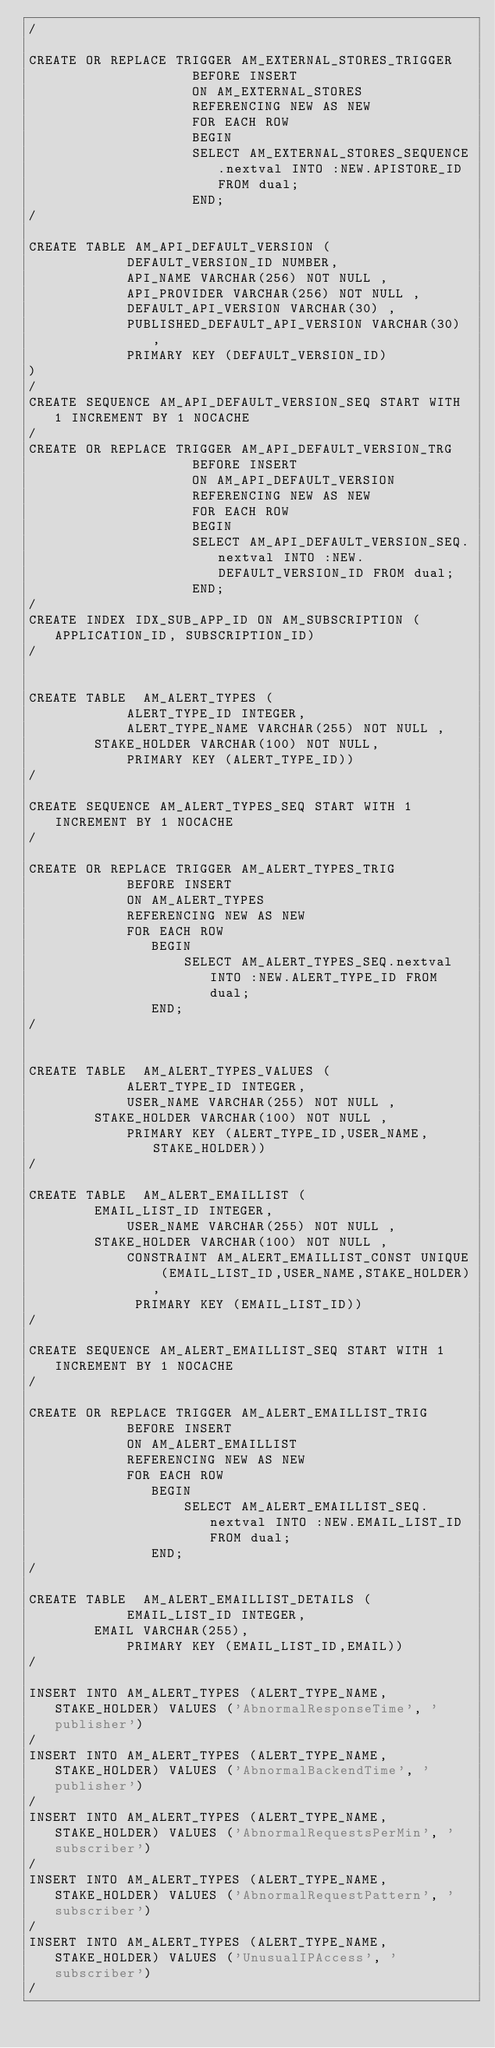<code> <loc_0><loc_0><loc_500><loc_500><_SQL_>/

CREATE OR REPLACE TRIGGER AM_EXTERNAL_STORES_TRIGGER
		            BEFORE INSERT
                    ON AM_EXTERNAL_STORES
                    REFERENCING NEW AS NEW
                    FOR EACH ROW
                    BEGIN
                    SELECT AM_EXTERNAL_STORES_SEQUENCE.nextval INTO :NEW.APISTORE_ID FROM dual;
                    END;
/

CREATE TABLE AM_API_DEFAULT_VERSION (
            DEFAULT_VERSION_ID NUMBER,
            API_NAME VARCHAR(256) NOT NULL ,
            API_PROVIDER VARCHAR(256) NOT NULL ,
            DEFAULT_API_VERSION VARCHAR(30) ,
            PUBLISHED_DEFAULT_API_VERSION VARCHAR(30) ,
            PRIMARY KEY (DEFAULT_VERSION_ID)
)
/
CREATE SEQUENCE AM_API_DEFAULT_VERSION_SEQ START WITH 1 INCREMENT BY 1 NOCACHE
/
CREATE OR REPLACE TRIGGER AM_API_DEFAULT_VERSION_TRG
                    BEFORE INSERT
                    ON AM_API_DEFAULT_VERSION
                    REFERENCING NEW AS NEW
                    FOR EACH ROW
                    BEGIN
                    SELECT AM_API_DEFAULT_VERSION_SEQ.nextval INTO :NEW.DEFAULT_VERSION_ID FROM dual;
                    END;
/
CREATE INDEX IDX_SUB_APP_ID ON AM_SUBSCRIPTION (APPLICATION_ID, SUBSCRIPTION_ID)
/


CREATE TABLE  AM_ALERT_TYPES (
            ALERT_TYPE_ID INTEGER,
            ALERT_TYPE_NAME VARCHAR(255) NOT NULL ,
	    STAKE_HOLDER VARCHAR(100) NOT NULL,
            PRIMARY KEY (ALERT_TYPE_ID))
/

CREATE SEQUENCE AM_ALERT_TYPES_SEQ START WITH 1 INCREMENT BY 1 NOCACHE
/

CREATE OR REPLACE TRIGGER AM_ALERT_TYPES_TRIG
            BEFORE INSERT
            ON AM_ALERT_TYPES
            REFERENCING NEW AS NEW
            FOR EACH ROW
               BEGIN
                   SELECT AM_ALERT_TYPES_SEQ.nextval INTO :NEW.ALERT_TYPE_ID FROM dual;
               END;
/


CREATE TABLE  AM_ALERT_TYPES_VALUES (
            ALERT_TYPE_ID INTEGER,
            USER_NAME VARCHAR(255) NOT NULL ,
	    STAKE_HOLDER VARCHAR(100) NOT NULL ,
	        PRIMARY KEY (ALERT_TYPE_ID,USER_NAME,STAKE_HOLDER))
/

CREATE TABLE  AM_ALERT_EMAILLIST (
	    EMAIL_LIST_ID INTEGER,
            USER_NAME VARCHAR(255) NOT NULL ,
	    STAKE_HOLDER VARCHAR(100) NOT NULL ,
            CONSTRAINT AM_ALERT_EMAILLIST_CONST UNIQUE (EMAIL_LIST_ID,USER_NAME,STAKE_HOLDER),
             PRIMARY KEY (EMAIL_LIST_ID))
/

CREATE SEQUENCE AM_ALERT_EMAILLIST_SEQ START WITH 1 INCREMENT BY 1 NOCACHE
/

CREATE OR REPLACE TRIGGER AM_ALERT_EMAILLIST_TRIG
            BEFORE INSERT
            ON AM_ALERT_EMAILLIST
            REFERENCING NEW AS NEW
            FOR EACH ROW
               BEGIN
                   SELECT AM_ALERT_EMAILLIST_SEQ.nextval INTO :NEW.EMAIL_LIST_ID FROM dual;
               END;
/

CREATE TABLE  AM_ALERT_EMAILLIST_DETAILS (
            EMAIL_LIST_ID INTEGER,
	    EMAIL VARCHAR(255),
	        PRIMARY KEY (EMAIL_LIST_ID,EMAIL))
/

INSERT INTO AM_ALERT_TYPES (ALERT_TYPE_NAME, STAKE_HOLDER) VALUES ('AbnormalResponseTime', 'publisher')
/
INSERT INTO AM_ALERT_TYPES (ALERT_TYPE_NAME, STAKE_HOLDER) VALUES ('AbnormalBackendTime', 'publisher')
/
INSERT INTO AM_ALERT_TYPES (ALERT_TYPE_NAME, STAKE_HOLDER) VALUES ('AbnormalRequestsPerMin', 'subscriber')
/
INSERT INTO AM_ALERT_TYPES (ALERT_TYPE_NAME, STAKE_HOLDER) VALUES ('AbnormalRequestPattern', 'subscriber')
/
INSERT INTO AM_ALERT_TYPES (ALERT_TYPE_NAME, STAKE_HOLDER) VALUES ('UnusualIPAccess', 'subscriber')
/</code> 